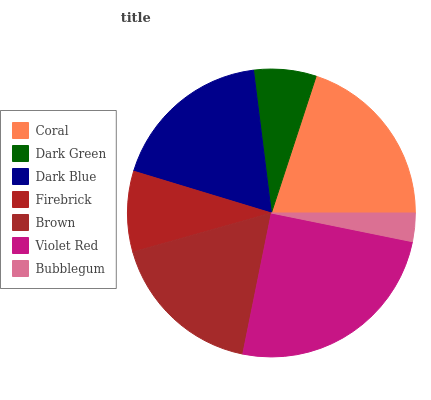Is Bubblegum the minimum?
Answer yes or no. Yes. Is Violet Red the maximum?
Answer yes or no. Yes. Is Dark Green the minimum?
Answer yes or no. No. Is Dark Green the maximum?
Answer yes or no. No. Is Coral greater than Dark Green?
Answer yes or no. Yes. Is Dark Green less than Coral?
Answer yes or no. Yes. Is Dark Green greater than Coral?
Answer yes or no. No. Is Coral less than Dark Green?
Answer yes or no. No. Is Brown the high median?
Answer yes or no. Yes. Is Brown the low median?
Answer yes or no. Yes. Is Dark Blue the high median?
Answer yes or no. No. Is Coral the low median?
Answer yes or no. No. 